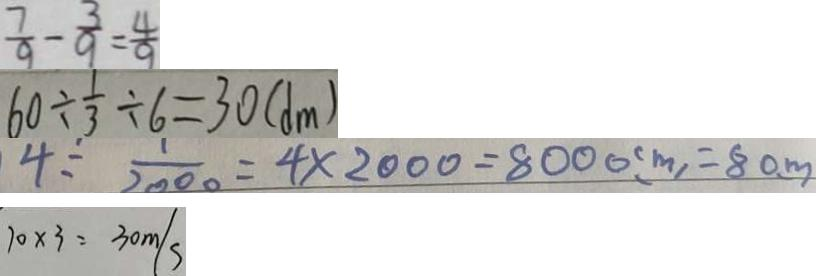<formula> <loc_0><loc_0><loc_500><loc_500>\frac { 7 } { 9 } - \frac { 3 } { 9 } = \frac { 4 } { 9 } 
 6 0 \div \frac { 1 } { 3 } \div 6 = 3 0 ( d m ) 
 4 \div \frac { 1 } { 2 0 0 0 } = 4 \times 2 0 0 0 = 8 0 0 0 ( m ) = 8 0 m 
 1 0 \times 3 = 3 0 m / s</formula> 